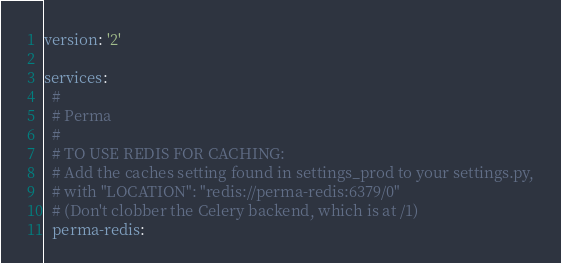<code> <loc_0><loc_0><loc_500><loc_500><_YAML_>version: '2'

services:
  #
  # Perma
  #
  # TO USE REDIS FOR CACHING:
  # Add the caches setting found in settings_prod to your settings.py,
  # with "LOCATION": "redis://perma-redis:6379/0"
  # (Don't clobber the Celery backend, which is at /1)
  perma-redis:</code> 